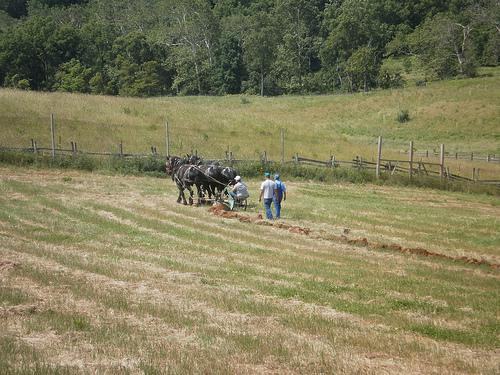Question: what are they doing?
Choices:
A. Plowing.
B. Farming.
C. Planting.
D. Watering.
Answer with the letter. Answer: A Question: why are they plowing?
Choices:
A. For their farm.
B. For their garden.
C. For their plants.
D. For the crops.
Answer with the letter. Answer: D Question: where is this scene?
Choices:
A. The crop field.
B. The farm.
C. The barn.
D. The country.
Answer with the letter. Answer: B Question: who are the men?
Choices:
A. Farmers.
B. Workers.
C. Farm boys.
D. Helpers.
Answer with the letter. Answer: A Question: what is the purpose?
Choices:
A. To grow food.
B. To make food to survive the winter.
C. To make money.
D. To farm.
Answer with the letter. Answer: D 